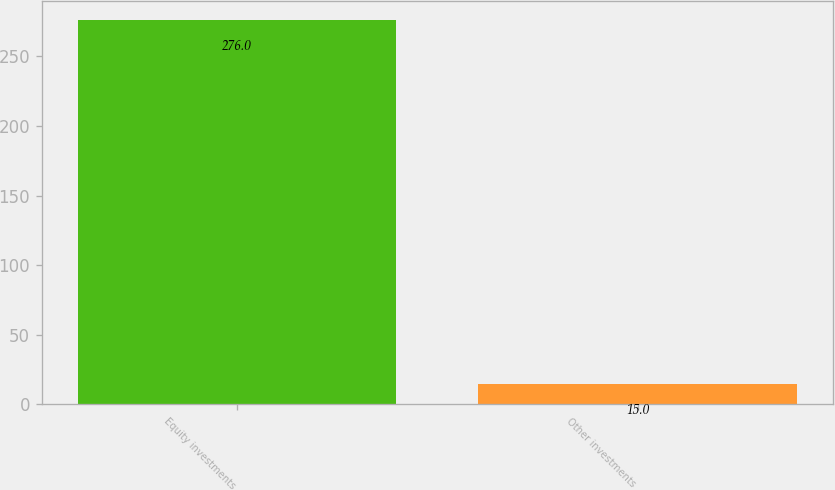Convert chart to OTSL. <chart><loc_0><loc_0><loc_500><loc_500><bar_chart><fcel>Equity investments<fcel>Other investments<nl><fcel>276<fcel>15<nl></chart> 